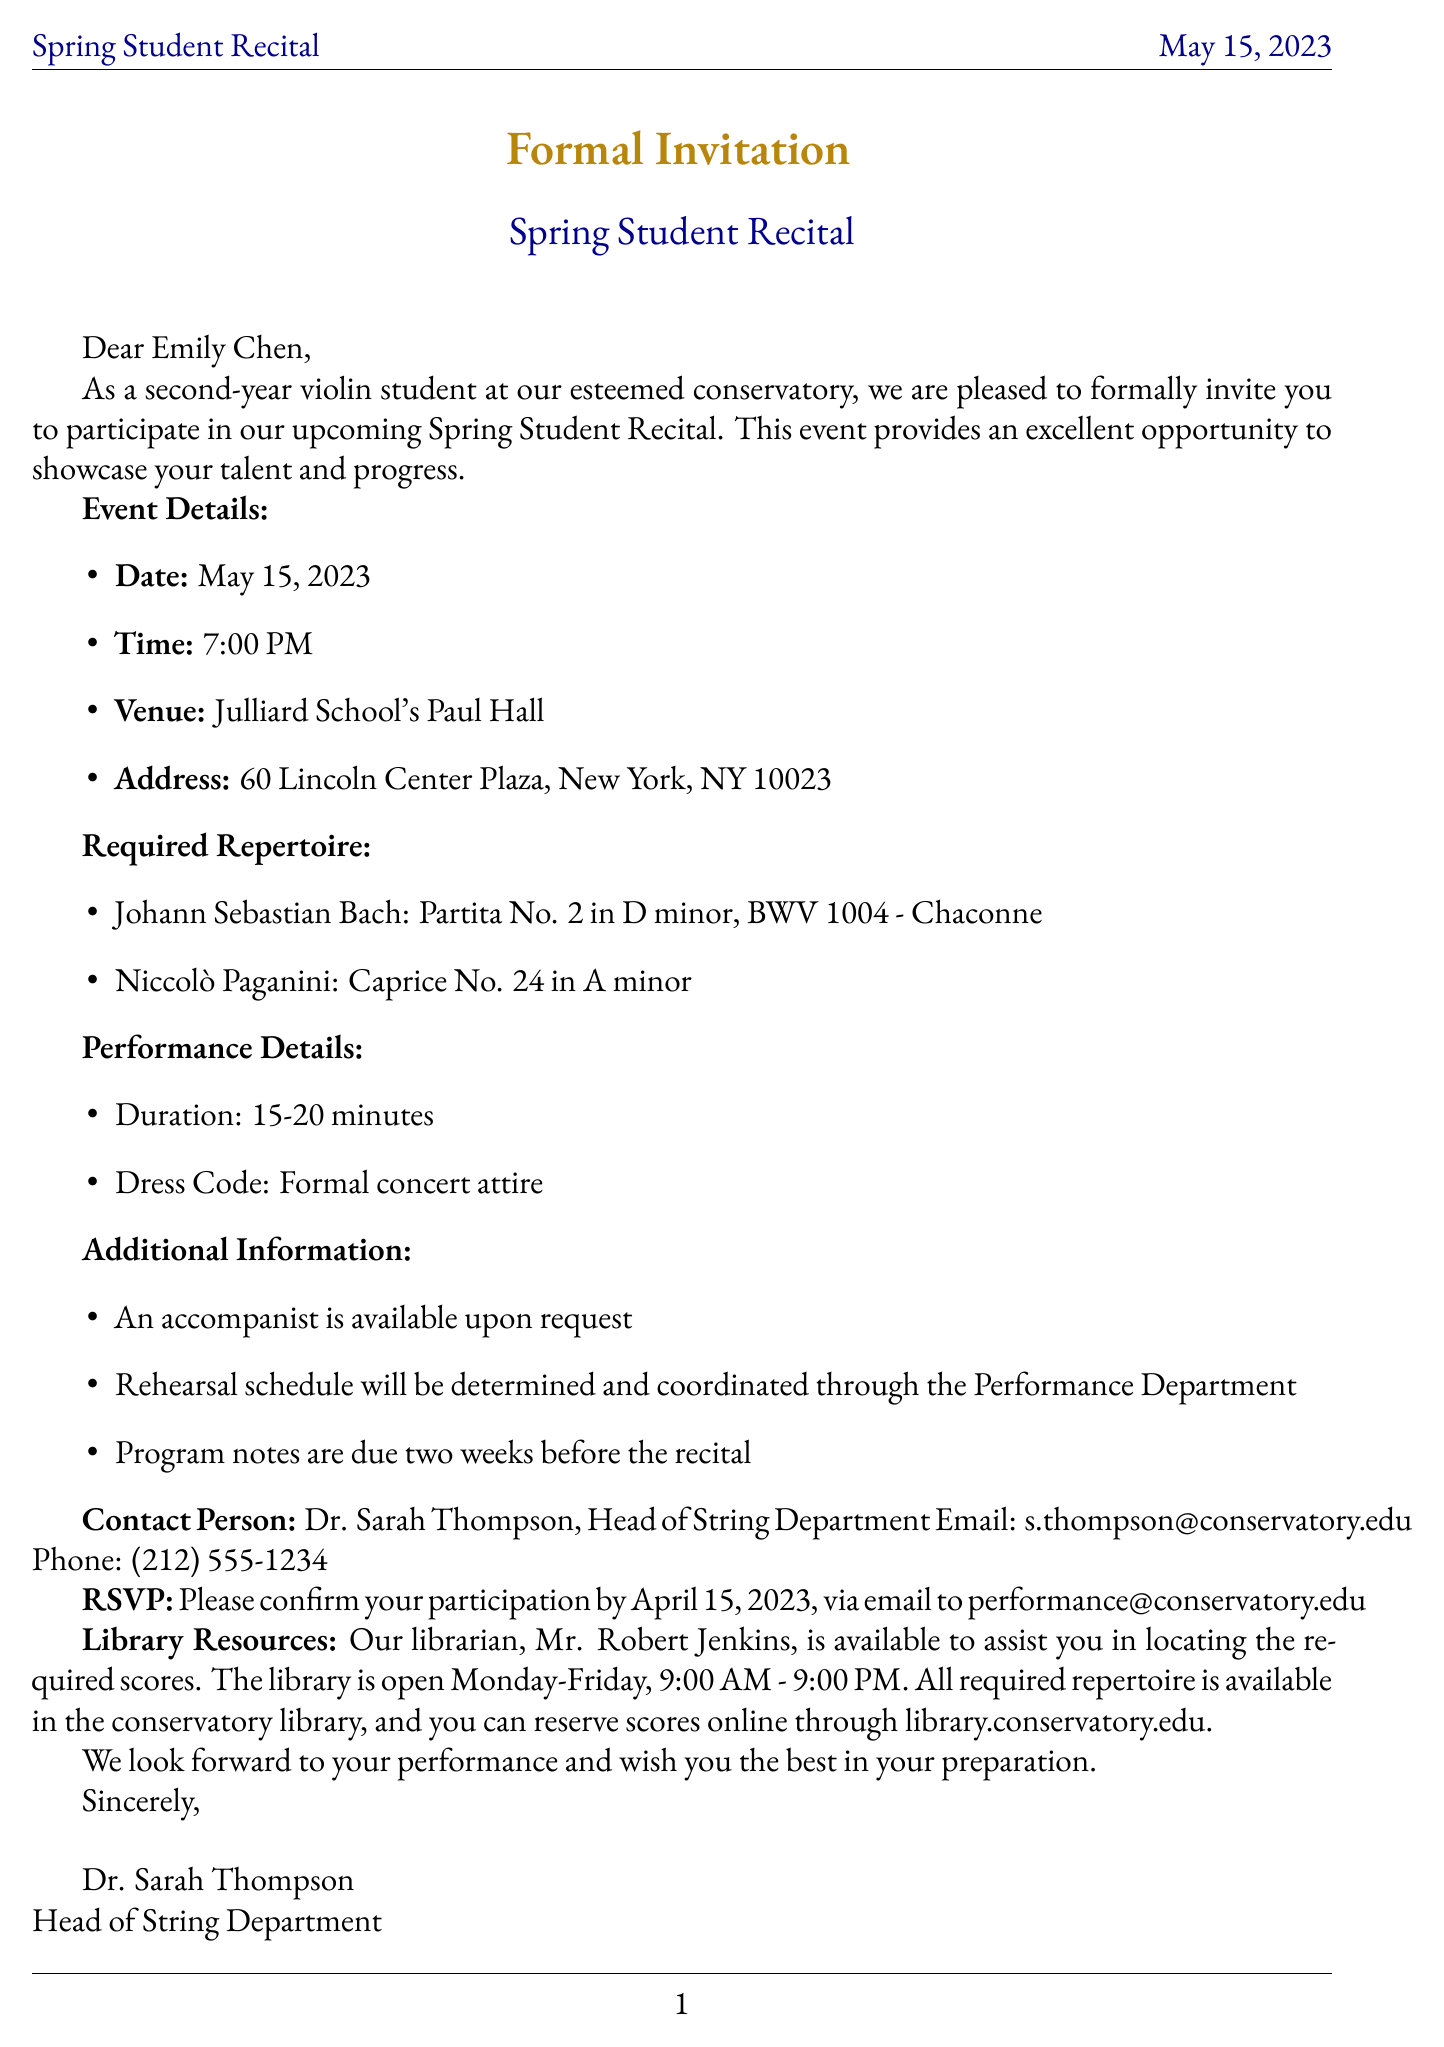What is the name of the event? The event is called the Spring Student Recital, as stated in the document.
Answer: Spring Student Recital What is the date of the recital? The recital is scheduled for May 15, 2023, as mentioned in the event details.
Answer: May 15, 2023 Who is the recipient of the invitation? The invitation is addressed to Emily Chen, which is specified in the document.
Answer: Emily Chen What is the duration of the performance? The document states that the performance duration is 15-20 minutes.
Answer: 15-20 minutes What is the dress code for the recital? The dress code is specified in the performance details as formal concert attire.
Answer: Formal concert attire What are the required pieces to perform? The document lists Bach's Partita No. 2 and Paganini's Caprice No. 24 as required repertoire.
Answer: Partita No. 2 in D minor, BWV 1004 - Chaconne and Caprice No. 24 in A minor When is the RSVP deadline? The RSVP deadline is specified as April 15, 2023, in the document.
Answer: April 15, 2023 Who can be contacted for more information? Dr. Sarah Thompson is listed as the contact person in the document.
Answer: Dr. Sarah Thompson Where is the library located? The library is located at the conservatory, with specific hours mentioned in the document.
Answer: Conservatory Library 